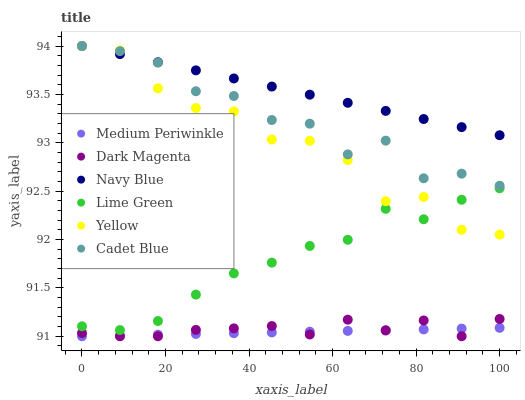Does Medium Periwinkle have the minimum area under the curve?
Answer yes or no. Yes. Does Navy Blue have the maximum area under the curve?
Answer yes or no. Yes. Does Dark Magenta have the minimum area under the curve?
Answer yes or no. No. Does Dark Magenta have the maximum area under the curve?
Answer yes or no. No. Is Medium Periwinkle the smoothest?
Answer yes or no. Yes. Is Yellow the roughest?
Answer yes or no. Yes. Is Dark Magenta the smoothest?
Answer yes or no. No. Is Dark Magenta the roughest?
Answer yes or no. No. Does Dark Magenta have the lowest value?
Answer yes or no. Yes. Does Navy Blue have the lowest value?
Answer yes or no. No. Does Navy Blue have the highest value?
Answer yes or no. Yes. Does Dark Magenta have the highest value?
Answer yes or no. No. Is Lime Green less than Navy Blue?
Answer yes or no. Yes. Is Navy Blue greater than Lime Green?
Answer yes or no. Yes. Does Yellow intersect Cadet Blue?
Answer yes or no. Yes. Is Yellow less than Cadet Blue?
Answer yes or no. No. Is Yellow greater than Cadet Blue?
Answer yes or no. No. Does Lime Green intersect Navy Blue?
Answer yes or no. No. 